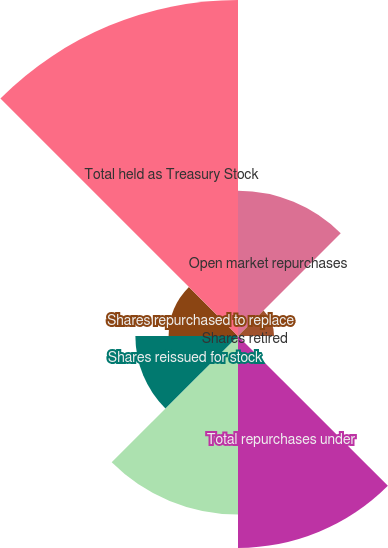Convert chart to OTSL. <chart><loc_0><loc_0><loc_500><loc_500><pie_chart><fcel>Open market repurchases<fcel>Repurchases from the Milton<fcel>Shares retired<fcel>Total repurchases under<fcel>Privately negotiated purchases<fcel>Shares reissued for stock<fcel>Shares repurchased to replace<fcel>Total held as Treasury Stock<nl><fcel>13.42%<fcel>3.33%<fcel>0.25%<fcel>19.58%<fcel>16.5%<fcel>9.48%<fcel>6.41%<fcel>31.04%<nl></chart> 